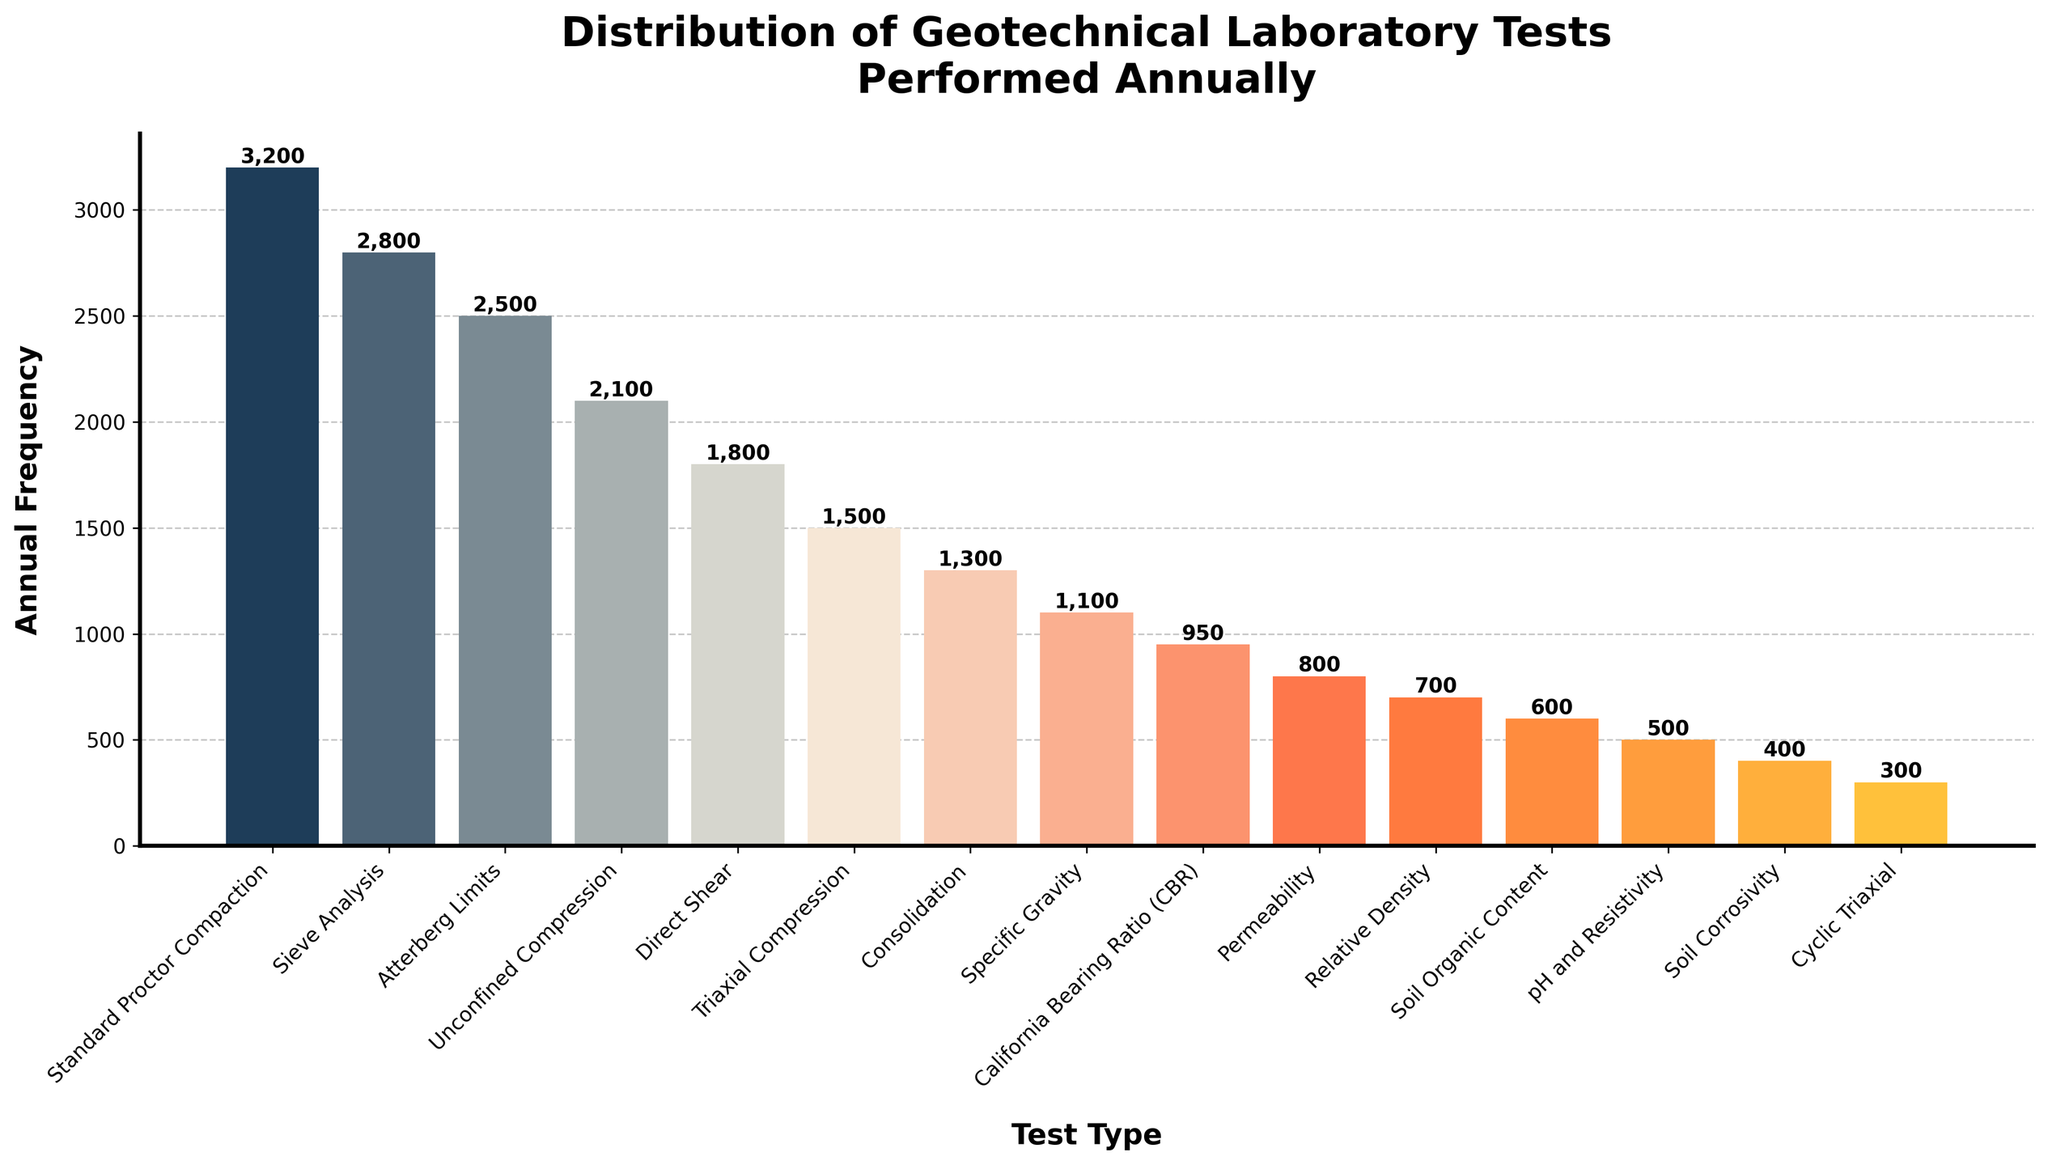Which geotechnical laboratory test is performed most frequently annually? The figure shows bar heights representing different test frequencies. The highest bar corresponds to the Standard Proctor Compaction test. Thus, this is the most frequently performed test.
Answer: Standard Proctor Compaction Which test is performed more frequently, Unconfined Compression or Direct Shear? By comparing the heights of the bars for Unconfined Compression and Direct Shear, we see that the Unconfined Compression bar is taller. Thus, Unconfined Compression is performed more frequently.
Answer: Unconfined Compression How many tests have an annual frequency greater than 2000? Count the number of bars with heights above the 2000 mark on the y-axis. Standard Proctor Compaction, Sieve Analysis, and Atterberg Limits have frequencies greater than 2000. There are three such tests.
Answer: 3 What's the sum of the annual frequencies of the top three most frequently performed tests? The top three tests are Standard Proctor Compaction (3200), Sieve Analysis (2800), and Atterberg Limits (2500). Summing these gives 3200 + 2800 + 2500 = 8500.
Answer: 8500 Which test is represented by a bar with medium height among the tests listed? To find the "medium" or median value, we look for the middle value in the sorted list of frequencies. With 15 tests, the 8th value in the sorted order is Specific Gravity (1100).
Answer: Specific Gravity For tests performed annually between 1000 and 2000 times, what is their combined frequency? Identify tests with frequencies in the range: Direct Shear (1800), Triaxial Compression (1500), Consolidation (1300), Specific Gravity (1100), and California Bearing Ratio (CBR) (950). Summing them: 1800 + 1500 + 1300 + 1100 + 950 = 6650.
Answer: 6650 Which test's frequency is exactly 1000 times higher than the Relative Density test? Look for the bar with a frequency of 1700, as Relative Density has a frequency of 700. No such bar exists, so no test fits this description exactly.
Answer: None Comparing California Bearing Ratio (CBR) and Permeability tests, which one has a higher frequency, and by how much? California Bearing Ratio (CBR) has a frequency of 950, while Permeability has 800. The difference is 950 - 800 = 150.
Answer: CBR by 150 How many tests are performed less frequently than 600 times annually? Count the bars below the 600 mark: pH and Resistivity (500), Soil Corrosivity (400), cyclic triaxial (300). There are 3 such tests.
Answer: 3 